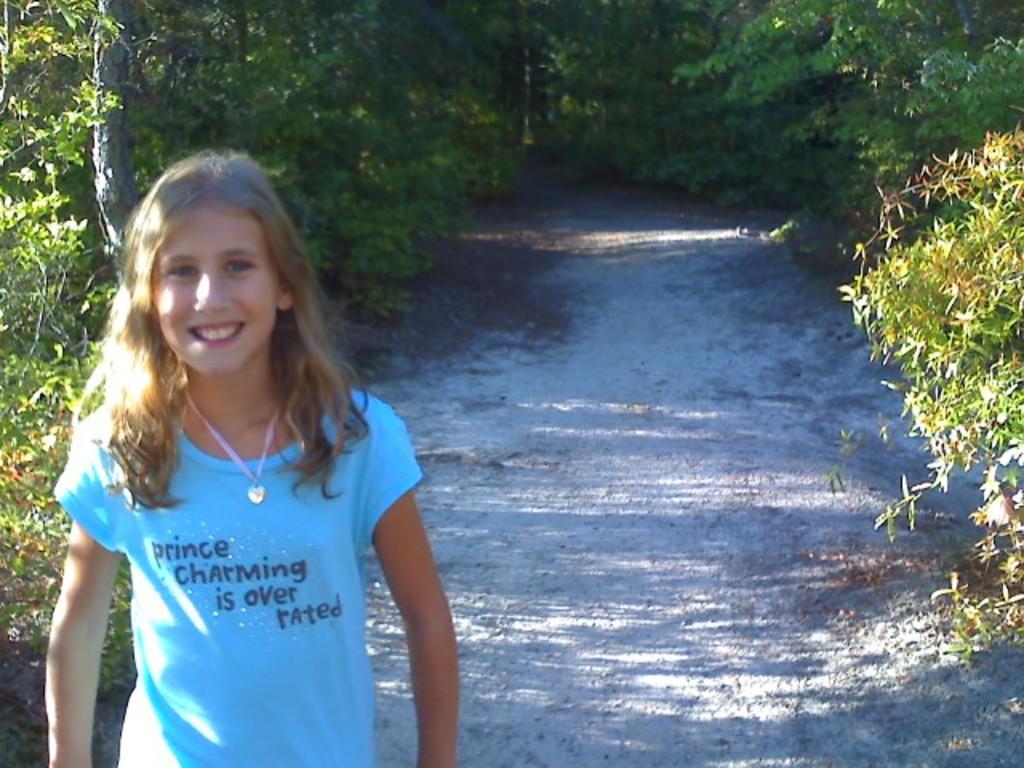Could you give a brief overview of what you see in this image? In this image, we can see a path in between trees. There is a kid in the bottom left of the image wearing clothes. 